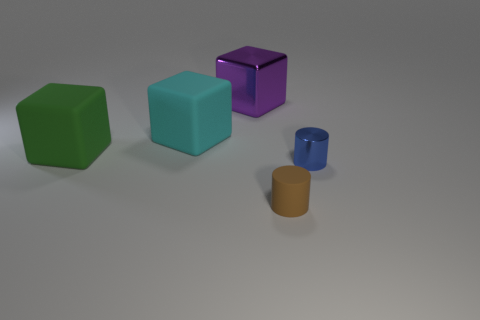There is a cylinder that is behind the rubber object that is on the right side of the purple thing; is there a small brown cylinder on the left side of it?
Your answer should be compact. Yes. The brown rubber thing has what size?
Offer a terse response. Small. What size is the metallic object that is behind the small blue metallic object?
Offer a terse response. Large. There is a thing on the right side of the brown matte object; is it the same size as the cyan rubber block?
Your answer should be very brief. No. Are there any other things that are the same color as the shiny cube?
Make the answer very short. No. There is a tiny brown rubber thing; what shape is it?
Offer a terse response. Cylinder. How many matte objects are on the right side of the green matte thing and behind the tiny brown matte object?
Your response must be concise. 1. There is another small object that is the same shape as the brown rubber thing; what is it made of?
Your answer should be very brief. Metal. Are there an equal number of small brown things in front of the brown thing and rubber cylinders that are behind the green block?
Provide a short and direct response. Yes. Is the material of the green thing the same as the brown cylinder?
Ensure brevity in your answer.  Yes. 